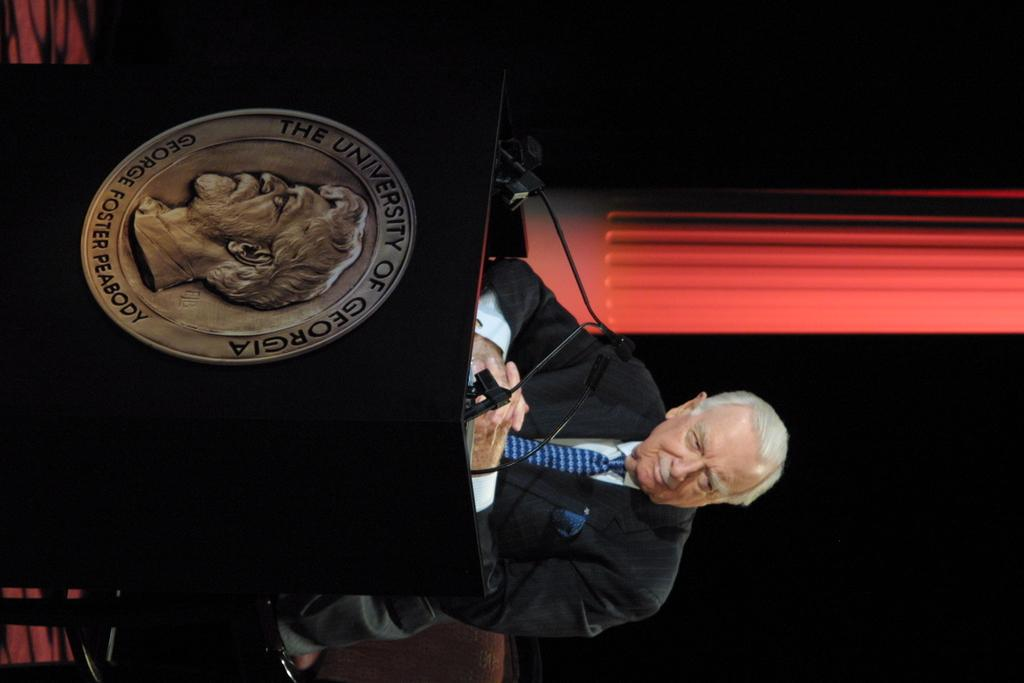<image>
Describe the image concisely. A man speaks at the university of georgia 